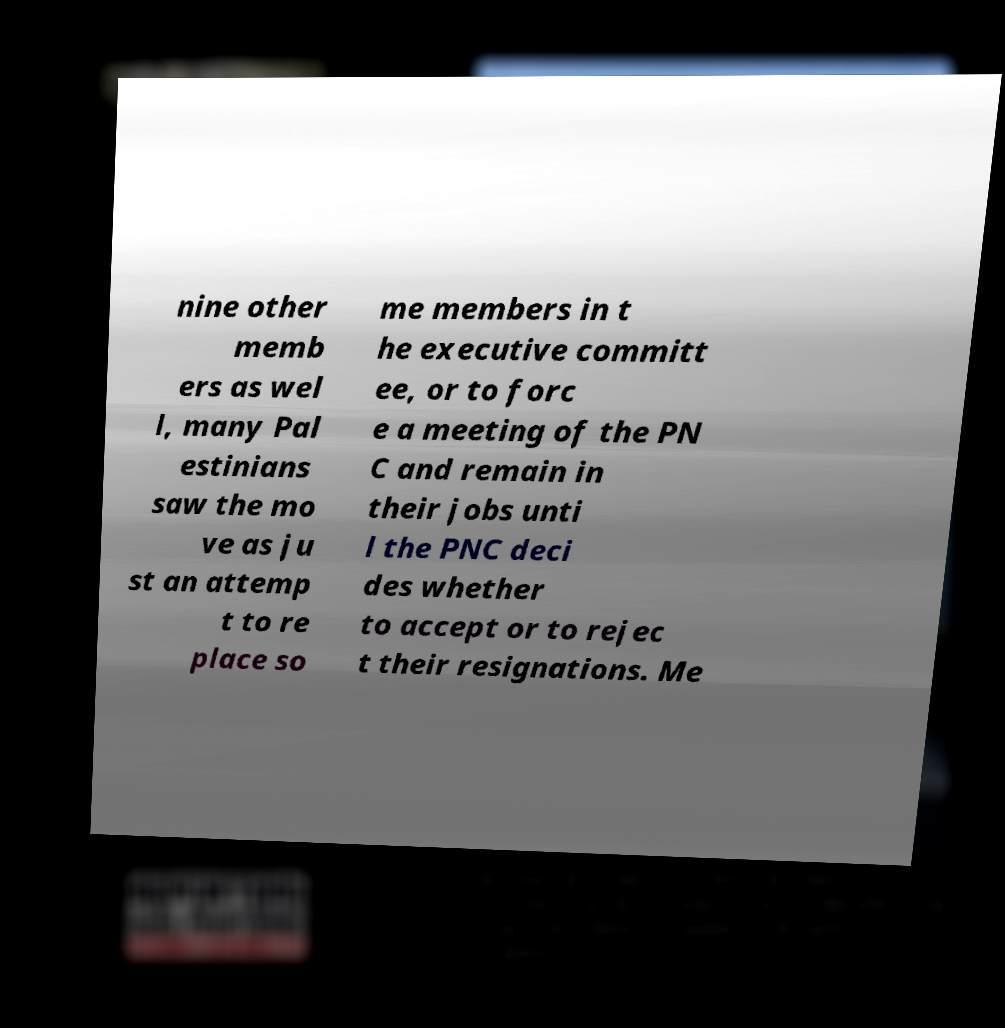Please identify and transcribe the text found in this image. nine other memb ers as wel l, many Pal estinians saw the mo ve as ju st an attemp t to re place so me members in t he executive committ ee, or to forc e a meeting of the PN C and remain in their jobs unti l the PNC deci des whether to accept or to rejec t their resignations. Me 